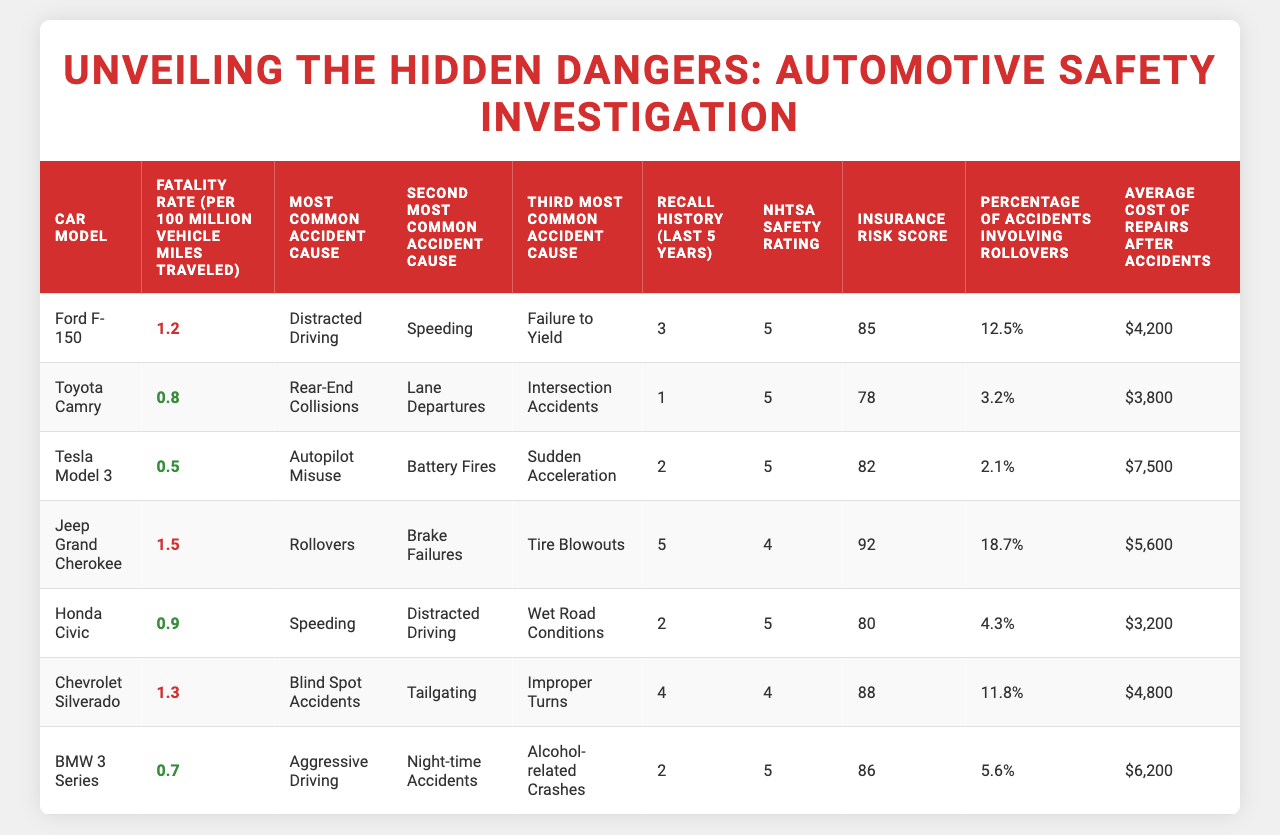What is the fatality rate of the Jeep Grand Cherokee? The table shows that the fatality rate for the Jeep Grand Cherokee is 1.5 per 100 million vehicle miles traveled.
Answer: 1.5 Which car model has the lowest fatality rate? According to the table, the Tesla Model 3 has the lowest fatality rate at 0.5 per 100 million vehicle miles traveled.
Answer: Tesla Model 3 Is there a correlation between a higher insurance risk score and a higher fatality rate? The table indicates that the Jeep Grand Cherokee has the highest fatality rate (1.5) and the highest insurance risk score (92), while the Toyota Camry has a lower fatality rate (0.8) and a lower insurance score (78). This suggests a possible trend.
Answer: Yes How many recalls has the Toyota Camry had in the last five years? The table directly shows that the Toyota Camry has had 1 recall in the last five years.
Answer: 1 What is the average cost of repairs for the top three cars listed in terms of fatality rates? The average cost of repairs can be calculated by adding the costs of the top three: Ford F-150 ($4,200), Jeep Grand Cherokee ($5,600), Chevrolet Silverado ($4,800), which totals $14,600. Dividing by 3 gives an average of $4,866.67.
Answer: $4,866.67 Which car has the highest percentage of accidents involving rollovers? From the table, the Jeep Grand Cherokee has the highest percentage of accidents involving rollovers at 18.7%.
Answer: 18.7% Does the BMW 3 Series have a better NHTSA safety rating than the Chevrolet Silverado? The table shows that both the BMW 3 Series and the Chevrolet Silverado share a safety rating of 4. Therefore, the BMW does not have a better rating; they are equal.
Answer: No What are the second and third most common accident causes for the Tesla Model 3? The table indicates that the second most common cause is "Battery Fires" and the third is "Sudden Acceleration" for the Tesla Model 3.
Answer: Battery Fires; Sudden Acceleration If the recall history of the Ford F-150 increases by 2 in the next five years, how many recalls will it have? The Ford F-150 currently has 3 recalls. If it increases by 2, the total will be 3 + 2 = 5 recalls.
Answer: 5 How do the fatality rates compare between the Ford F-150 and the Honda Civic? By examining the table, the Ford F-150 has a fatality rate of 1.2, while the Honda Civic has a fatality rate of 0.9. Thus, the Ford F-150 has a higher fatality rate than the Honda Civic.
Answer: Ford F-150 is higher 